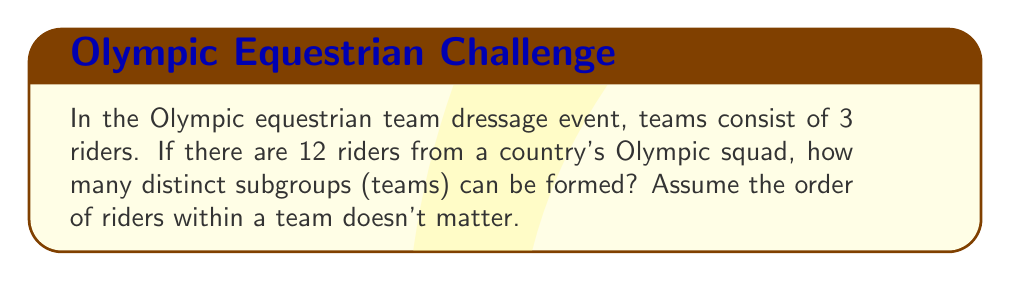What is the answer to this math problem? To solve this problem, we need to use concepts from group theory and combinatorics. Let's approach this step-by-step:

1) First, we need to recognize that this is a combination problem. We are selecting 3 riders from a group of 12, where the order doesn't matter.

2) In group theory, this is equivalent to finding the number of subgroups of order 3 in a group of order 12.

3) The formula for combinations is:

   $$C(n,r) = \frac{n!}{r!(n-r)!}$$

   where $n$ is the total number of elements and $r$ is the number of elements being chosen.

4) In this case, $n = 12$ (total riders) and $r = 3$ (riders per team).

5) Plugging these values into our formula:

   $$C(12,3) = \frac{12!}{3!(12-3)!} = \frac{12!}{3!9!}$$

6) Let's calculate this:
   
   $$\frac{12 \cdot 11 \cdot 10 \cdot 9!}{(3 \cdot 2 \cdot 1) \cdot 9!}$$

7) The 9! cancels out in the numerator and denominator:

   $$\frac{12 \cdot 11 \cdot 10}{3 \cdot 2 \cdot 1} = \frac{1320}{6} = 220$$

Therefore, there are 220 distinct subgroups (teams) that can be formed.
Answer: 220 distinct subgroups (teams) 